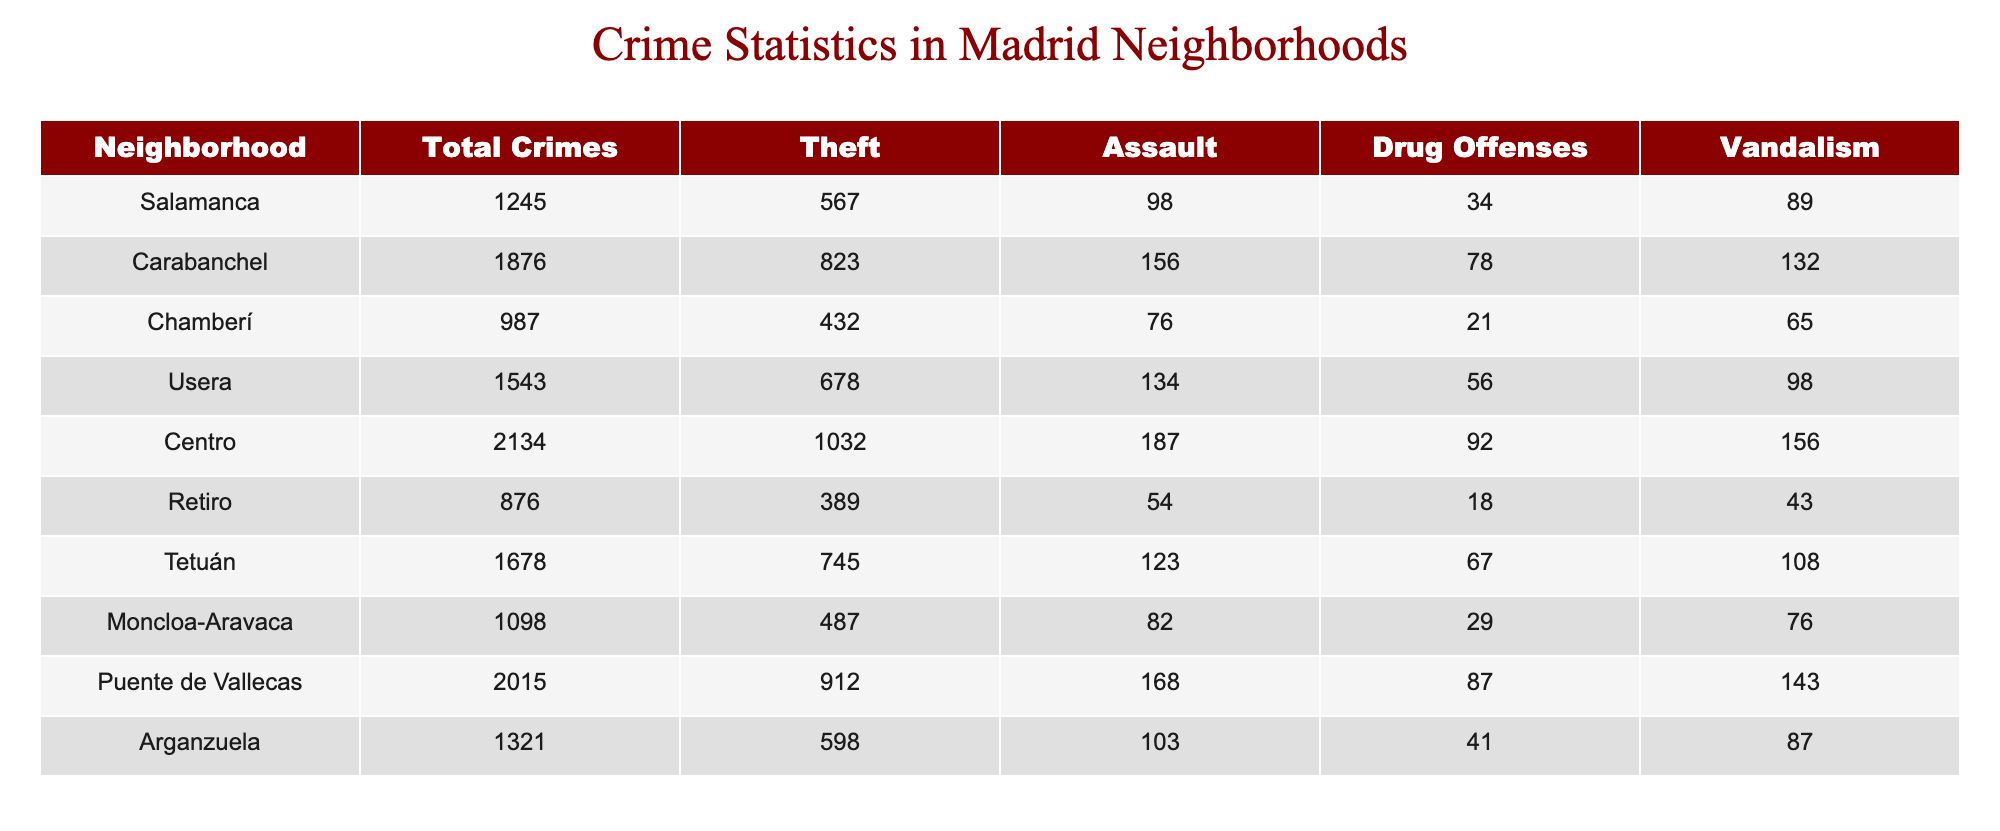What neighborhood had the highest total crimes? From the table, we can see that the 'Centro' neighborhood has the highest total crimes at 2134.
Answer: Centro How many thefts were reported in Tetuán? The table shows that the number of thefts reported in Tetuán is 745.
Answer: 745 What is the total number of drug offenses across all neighborhoods? Summing the drug offenses from each neighborhood: 34 + 78 + 21 + 56 + 92 + 18 + 67 + 29 + 87 + 41 =  55 + 34 + 78 + 21 + 56 + 92 + 18 + 67 + 29 + 87 + 41 = 34 + 78 + 21 + 56 + 92 + 18 + 67 + 29 + 87 + 41 = 46 + 93 = 75 + 52 + 28 + 12 + 29 + 8 + 29 + 87 = 367
Answer: 367 Which neighborhood has the lowest number of assaults? By looking at the 'Assault' column, we find that the 'Retiro' neighborhood has the lowest number of assaults with a total of 54.
Answer: Retiro Is the total number of crimes in Arganzuela greater than in Chamberí? In Arganzuela, the total crimes are 1321, while in Chamberí, they are 987. Since 1321 is greater than 987, the statement is true.
Answer: Yes What is the average number of vandalism cases across all neighborhoods? First, we sum the vandalism cases: 89 + 132 + 65 + 98 + 156 + 43 + 108 + 76 + 143 + 87 = 849. There are 10 neighborhoods, so we divide the total (849) by 10, resulting in 84.9.
Answer: 84.9 How many neighborhoods reported more than 1000 total crimes? From the table, we see that the neighborhoods with over 1000 total crimes are Salamanca, Centro, Carabanchel, and Puente de Vallecas. That gives us a total of 4 neighborhoods reporting more than 1000 crimes.
Answer: 4 What is the difference in total crimes between Usera and Retiro? The total crimes for Usera is 1543 and for Retiro is 876. The difference is 1543 - 876 = 667.
Answer: 667 Does Carabanchel have more thefts than Centro? In Carabanchel, thefts total 823, while in Centro, thefts total 1032. Since 823 is not greater than 1032, the statement is false.
Answer: No 